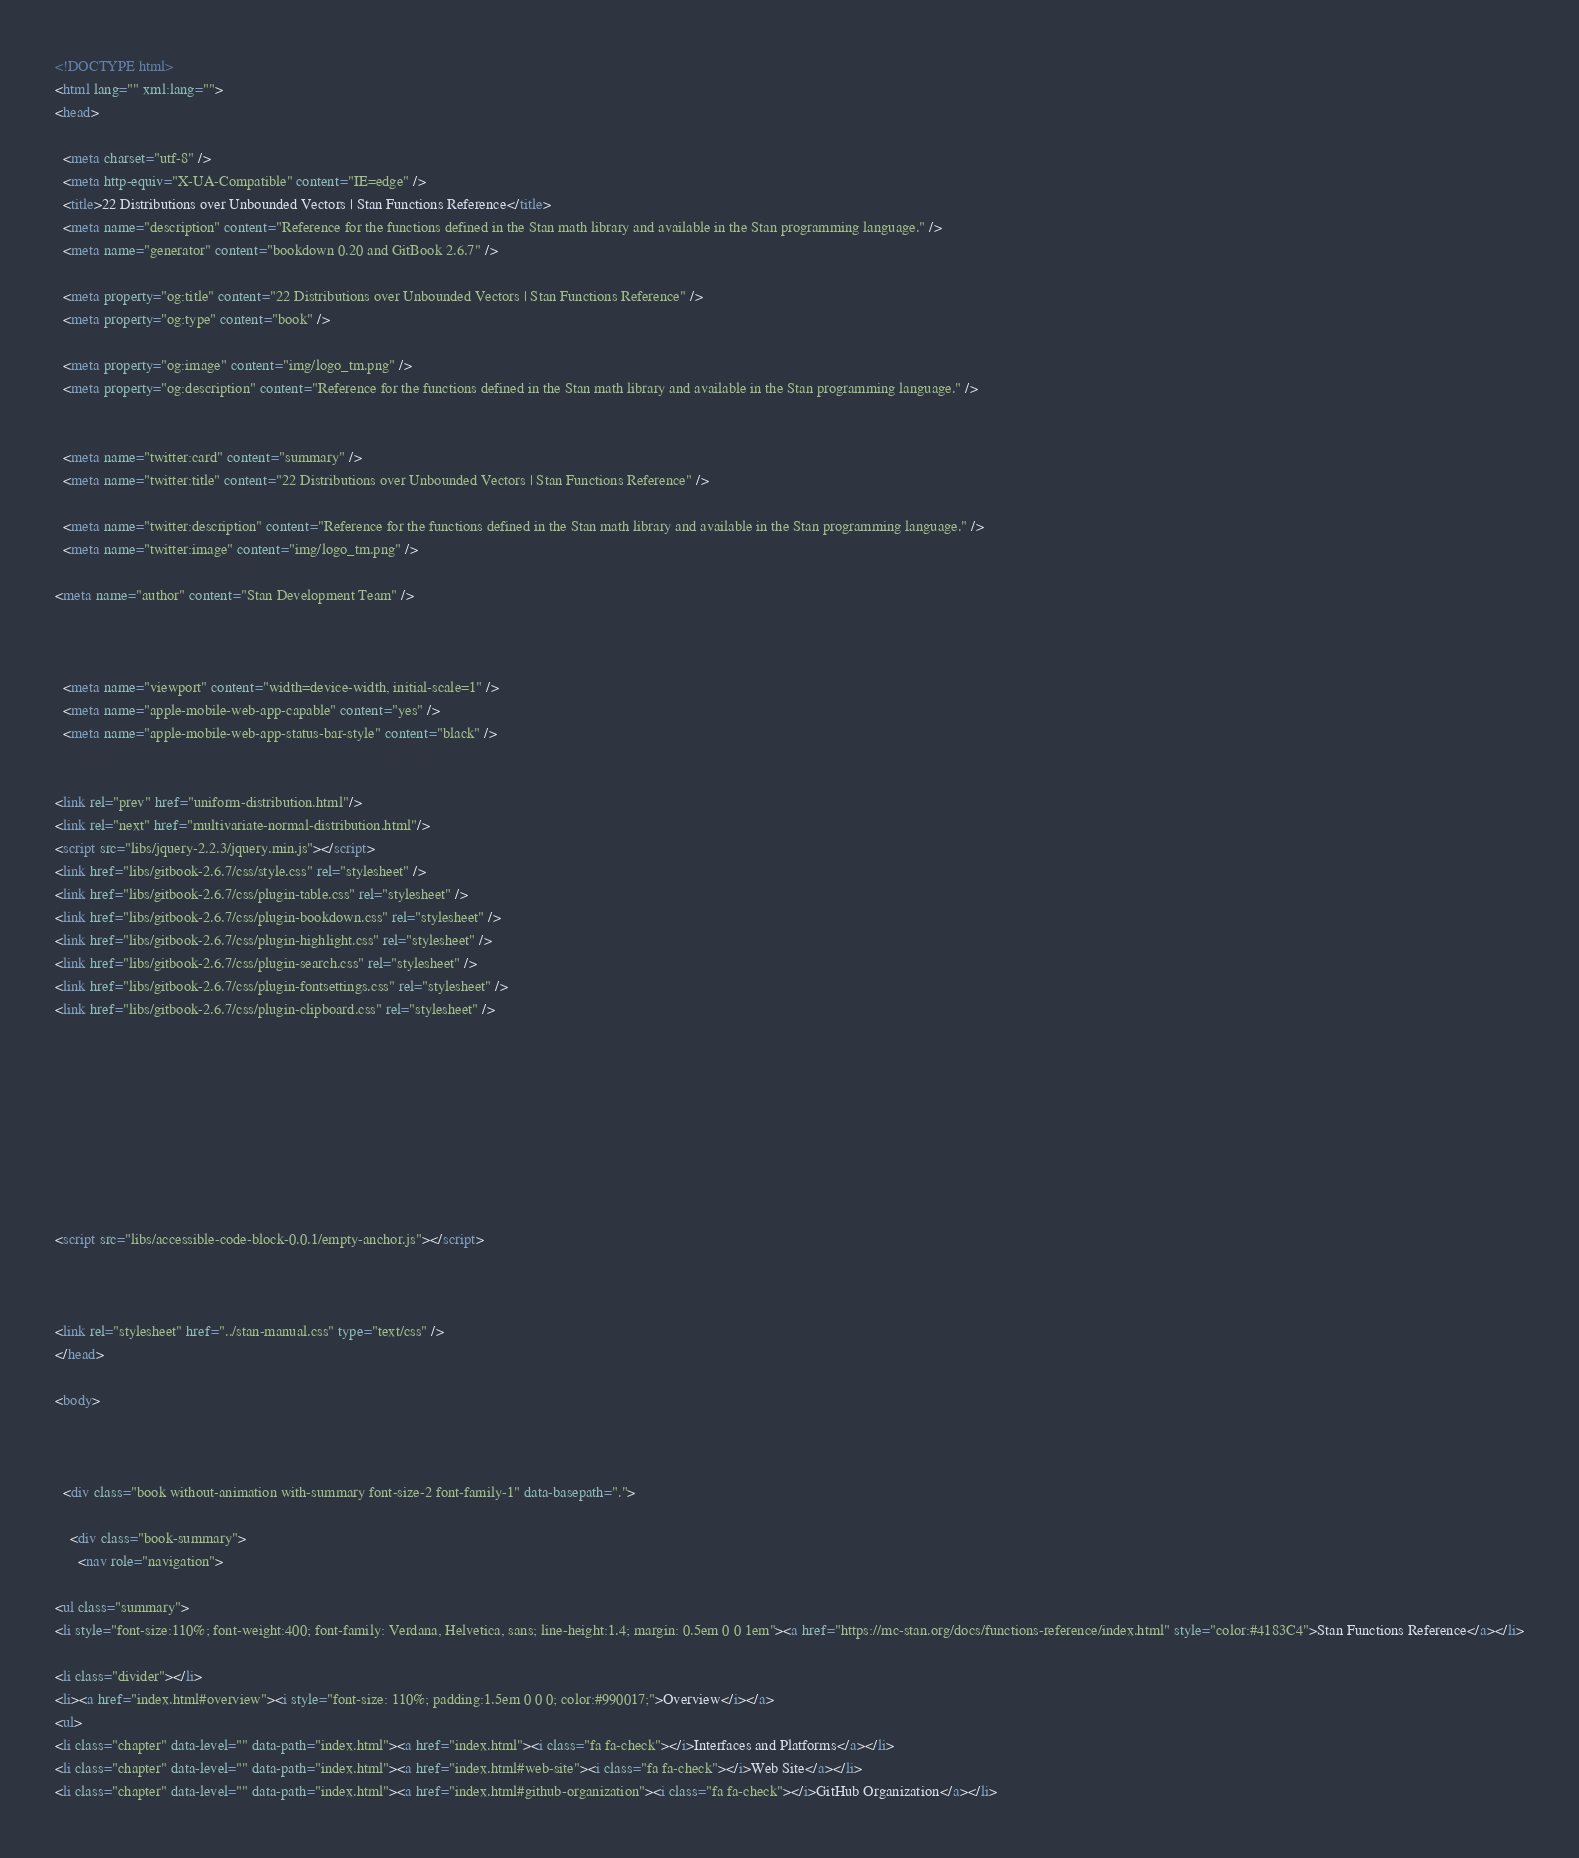Convert code to text. <code><loc_0><loc_0><loc_500><loc_500><_HTML_><!DOCTYPE html>
<html lang="" xml:lang="">
<head>

  <meta charset="utf-8" />
  <meta http-equiv="X-UA-Compatible" content="IE=edge" />
  <title>22 Distributions over Unbounded Vectors | Stan Functions Reference</title>
  <meta name="description" content="Reference for the functions defined in the Stan math library and available in the Stan programming language." />
  <meta name="generator" content="bookdown 0.20 and GitBook 2.6.7" />

  <meta property="og:title" content="22 Distributions over Unbounded Vectors | Stan Functions Reference" />
  <meta property="og:type" content="book" />
  
  <meta property="og:image" content="img/logo_tm.png" />
  <meta property="og:description" content="Reference for the functions defined in the Stan math library and available in the Stan programming language." />
  

  <meta name="twitter:card" content="summary" />
  <meta name="twitter:title" content="22 Distributions over Unbounded Vectors | Stan Functions Reference" />
  
  <meta name="twitter:description" content="Reference for the functions defined in the Stan math library and available in the Stan programming language." />
  <meta name="twitter:image" content="img/logo_tm.png" />

<meta name="author" content="Stan Development Team" />



  <meta name="viewport" content="width=device-width, initial-scale=1" />
  <meta name="apple-mobile-web-app-capable" content="yes" />
  <meta name="apple-mobile-web-app-status-bar-style" content="black" />
  
  
<link rel="prev" href="uniform-distribution.html"/>
<link rel="next" href="multivariate-normal-distribution.html"/>
<script src="libs/jquery-2.2.3/jquery.min.js"></script>
<link href="libs/gitbook-2.6.7/css/style.css" rel="stylesheet" />
<link href="libs/gitbook-2.6.7/css/plugin-table.css" rel="stylesheet" />
<link href="libs/gitbook-2.6.7/css/plugin-bookdown.css" rel="stylesheet" />
<link href="libs/gitbook-2.6.7/css/plugin-highlight.css" rel="stylesheet" />
<link href="libs/gitbook-2.6.7/css/plugin-search.css" rel="stylesheet" />
<link href="libs/gitbook-2.6.7/css/plugin-fontsettings.css" rel="stylesheet" />
<link href="libs/gitbook-2.6.7/css/plugin-clipboard.css" rel="stylesheet" />









<script src="libs/accessible-code-block-0.0.1/empty-anchor.js"></script>



<link rel="stylesheet" href="../stan-manual.css" type="text/css" />
</head>

<body>



  <div class="book without-animation with-summary font-size-2 font-family-1" data-basepath=".">

    <div class="book-summary">
      <nav role="navigation">

<ul class="summary">
<li style="font-size:110%; font-weight:400; font-family: Verdana, Helvetica, sans; line-height:1.4; margin: 0.5em 0 0 1em"><a href="https://mc-stan.org/docs/functions-reference/index.html" style="color:#4183C4">Stan Functions Reference</a></li>

<li class="divider"></li>
<li><a href="index.html#overview"><i style="font-size: 110%; padding:1.5em 0 0 0; color:#990017;">Overview</i></a>
<ul>
<li class="chapter" data-level="" data-path="index.html"><a href="index.html"><i class="fa fa-check"></i>Interfaces and Platforms</a></li>
<li class="chapter" data-level="" data-path="index.html"><a href="index.html#web-site"><i class="fa fa-check"></i>Web Site</a></li>
<li class="chapter" data-level="" data-path="index.html"><a href="index.html#github-organization"><i class="fa fa-check"></i>GitHub Organization</a></li></code> 